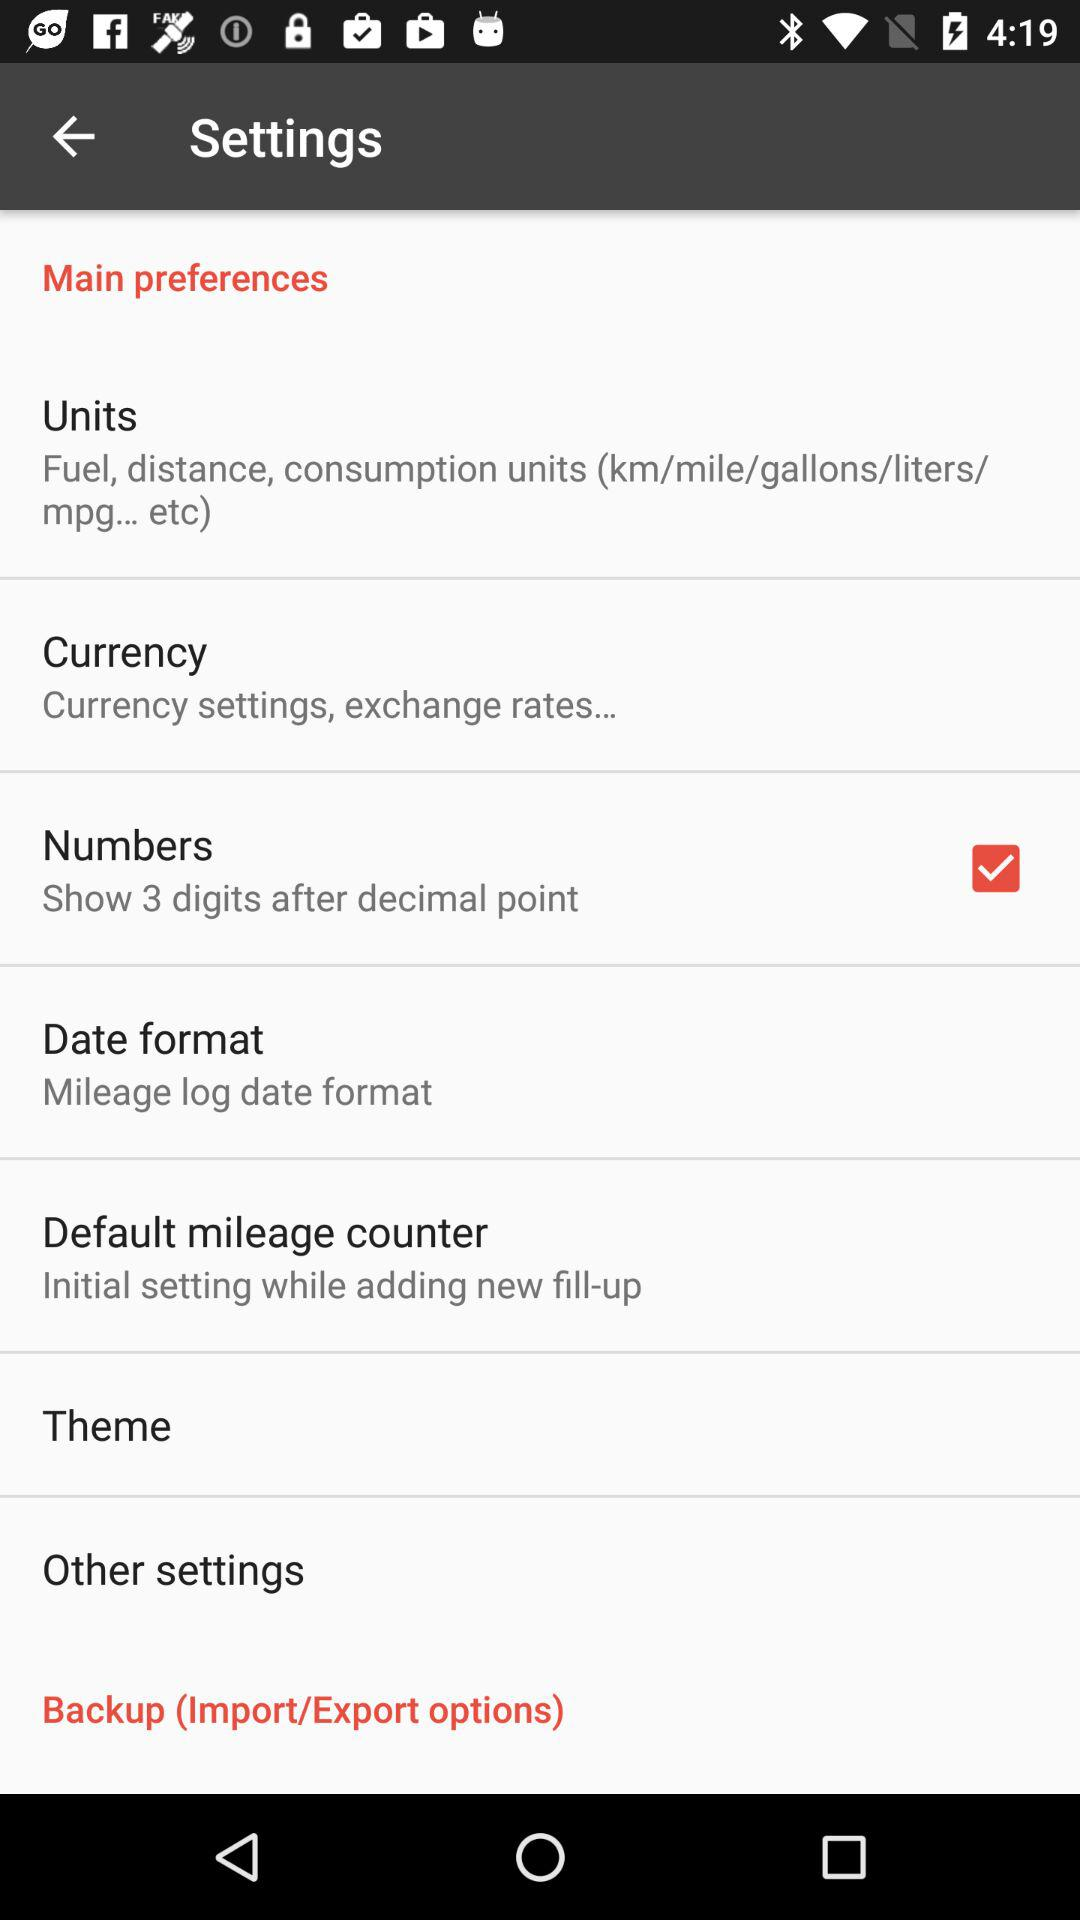What's the status of "Numbers"? The status of "Numbers" is "on". 